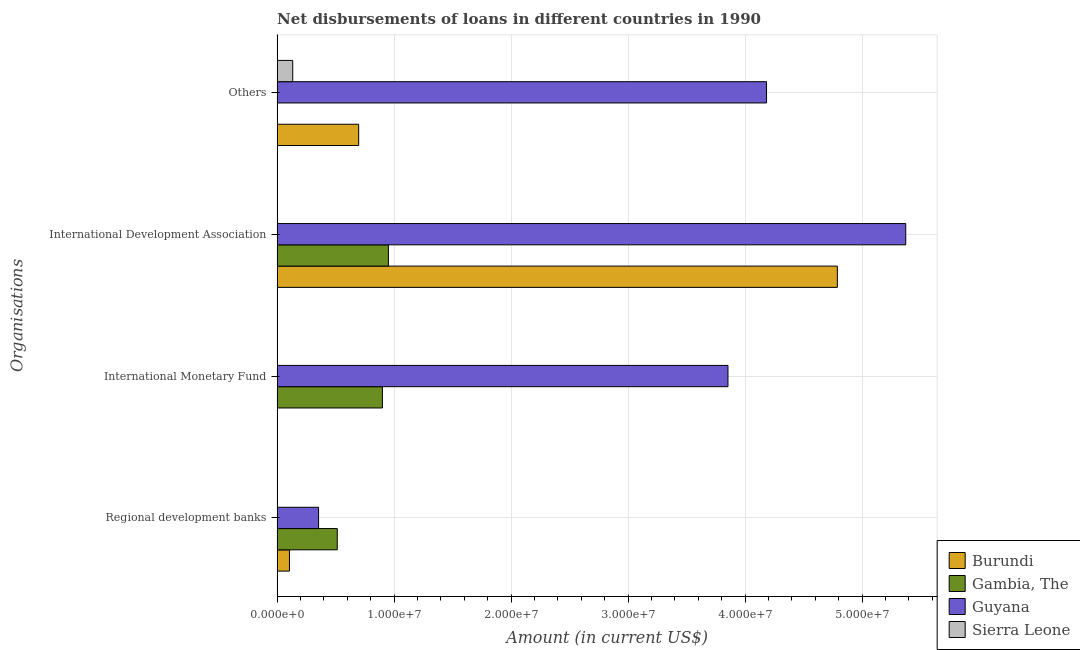How many different coloured bars are there?
Your response must be concise. 4. How many groups of bars are there?
Provide a succinct answer. 4. Are the number of bars per tick equal to the number of legend labels?
Provide a succinct answer. No. How many bars are there on the 4th tick from the bottom?
Your response must be concise. 3. What is the label of the 3rd group of bars from the top?
Provide a succinct answer. International Monetary Fund. What is the amount of loan disimbursed by international development association in Guyana?
Keep it short and to the point. 5.37e+07. Across all countries, what is the maximum amount of loan disimbursed by international monetary fund?
Ensure brevity in your answer.  3.85e+07. Across all countries, what is the minimum amount of loan disimbursed by regional development banks?
Keep it short and to the point. 0. In which country was the amount of loan disimbursed by international monetary fund maximum?
Your answer should be compact. Guyana. What is the total amount of loan disimbursed by other organisations in the graph?
Your answer should be compact. 5.01e+07. What is the difference between the amount of loan disimbursed by international development association in Gambia, The and that in Burundi?
Your response must be concise. -3.84e+07. What is the difference between the amount of loan disimbursed by regional development banks in Guyana and the amount of loan disimbursed by international development association in Burundi?
Your answer should be compact. -4.43e+07. What is the average amount of loan disimbursed by other organisations per country?
Keep it short and to the point. 1.25e+07. What is the difference between the amount of loan disimbursed by other organisations and amount of loan disimbursed by international development association in Burundi?
Make the answer very short. -4.09e+07. In how many countries, is the amount of loan disimbursed by international development association greater than 22000000 US$?
Ensure brevity in your answer.  2. What is the ratio of the amount of loan disimbursed by regional development banks in Gambia, The to that in Guyana?
Ensure brevity in your answer.  1.45. Is the amount of loan disimbursed by other organisations in Burundi less than that in Guyana?
Offer a very short reply. Yes. Is the difference between the amount of loan disimbursed by international development association in Sierra Leone and Guyana greater than the difference between the amount of loan disimbursed by other organisations in Sierra Leone and Guyana?
Provide a succinct answer. No. What is the difference between the highest and the second highest amount of loan disimbursed by regional development banks?
Offer a very short reply. 1.60e+06. What is the difference between the highest and the lowest amount of loan disimbursed by international development association?
Provide a succinct answer. 5.37e+07. Is it the case that in every country, the sum of the amount of loan disimbursed by regional development banks and amount of loan disimbursed by international monetary fund is greater than the amount of loan disimbursed by international development association?
Offer a very short reply. No. How many bars are there?
Keep it short and to the point. 12. Are all the bars in the graph horizontal?
Ensure brevity in your answer.  Yes. What is the difference between two consecutive major ticks on the X-axis?
Provide a succinct answer. 1.00e+07. Are the values on the major ticks of X-axis written in scientific E-notation?
Provide a short and direct response. Yes. Where does the legend appear in the graph?
Give a very brief answer. Bottom right. How are the legend labels stacked?
Make the answer very short. Vertical. What is the title of the graph?
Provide a short and direct response. Net disbursements of loans in different countries in 1990. Does "Small states" appear as one of the legend labels in the graph?
Give a very brief answer. No. What is the label or title of the Y-axis?
Provide a short and direct response. Organisations. What is the Amount (in current US$) in Burundi in Regional development banks?
Make the answer very short. 1.05e+06. What is the Amount (in current US$) in Gambia, The in Regional development banks?
Your answer should be compact. 5.14e+06. What is the Amount (in current US$) of Guyana in Regional development banks?
Keep it short and to the point. 3.54e+06. What is the Amount (in current US$) of Sierra Leone in Regional development banks?
Offer a terse response. 0. What is the Amount (in current US$) in Burundi in International Monetary Fund?
Your answer should be compact. 0. What is the Amount (in current US$) in Gambia, The in International Monetary Fund?
Provide a short and direct response. 9.00e+06. What is the Amount (in current US$) in Guyana in International Monetary Fund?
Offer a terse response. 3.85e+07. What is the Amount (in current US$) in Sierra Leone in International Monetary Fund?
Your response must be concise. 0. What is the Amount (in current US$) of Burundi in International Development Association?
Your answer should be compact. 4.79e+07. What is the Amount (in current US$) in Gambia, The in International Development Association?
Keep it short and to the point. 9.51e+06. What is the Amount (in current US$) in Guyana in International Development Association?
Make the answer very short. 5.37e+07. What is the Amount (in current US$) of Sierra Leone in International Development Association?
Your answer should be compact. 1.20e+04. What is the Amount (in current US$) in Burundi in Others?
Provide a succinct answer. 6.97e+06. What is the Amount (in current US$) of Guyana in Others?
Give a very brief answer. 4.18e+07. What is the Amount (in current US$) of Sierra Leone in Others?
Your answer should be compact. 1.33e+06. Across all Organisations, what is the maximum Amount (in current US$) in Burundi?
Provide a succinct answer. 4.79e+07. Across all Organisations, what is the maximum Amount (in current US$) in Gambia, The?
Offer a very short reply. 9.51e+06. Across all Organisations, what is the maximum Amount (in current US$) in Guyana?
Provide a short and direct response. 5.37e+07. Across all Organisations, what is the maximum Amount (in current US$) in Sierra Leone?
Provide a short and direct response. 1.33e+06. Across all Organisations, what is the minimum Amount (in current US$) in Burundi?
Provide a short and direct response. 0. Across all Organisations, what is the minimum Amount (in current US$) of Guyana?
Make the answer very short. 3.54e+06. What is the total Amount (in current US$) in Burundi in the graph?
Keep it short and to the point. 5.59e+07. What is the total Amount (in current US$) of Gambia, The in the graph?
Give a very brief answer. 2.36e+07. What is the total Amount (in current US$) in Guyana in the graph?
Provide a succinct answer. 1.38e+08. What is the total Amount (in current US$) in Sierra Leone in the graph?
Provide a short and direct response. 1.35e+06. What is the difference between the Amount (in current US$) in Gambia, The in Regional development banks and that in International Monetary Fund?
Offer a terse response. -3.86e+06. What is the difference between the Amount (in current US$) in Guyana in Regional development banks and that in International Monetary Fund?
Make the answer very short. -3.50e+07. What is the difference between the Amount (in current US$) of Burundi in Regional development banks and that in International Development Association?
Keep it short and to the point. -4.68e+07. What is the difference between the Amount (in current US$) in Gambia, The in Regional development banks and that in International Development Association?
Keep it short and to the point. -4.37e+06. What is the difference between the Amount (in current US$) of Guyana in Regional development banks and that in International Development Association?
Your answer should be compact. -5.02e+07. What is the difference between the Amount (in current US$) of Burundi in Regional development banks and that in Others?
Keep it short and to the point. -5.92e+06. What is the difference between the Amount (in current US$) in Guyana in Regional development banks and that in Others?
Provide a short and direct response. -3.83e+07. What is the difference between the Amount (in current US$) in Gambia, The in International Monetary Fund and that in International Development Association?
Give a very brief answer. -5.13e+05. What is the difference between the Amount (in current US$) of Guyana in International Monetary Fund and that in International Development Association?
Keep it short and to the point. -1.52e+07. What is the difference between the Amount (in current US$) in Guyana in International Monetary Fund and that in Others?
Your answer should be very brief. -3.30e+06. What is the difference between the Amount (in current US$) in Burundi in International Development Association and that in Others?
Your answer should be very brief. 4.09e+07. What is the difference between the Amount (in current US$) of Guyana in International Development Association and that in Others?
Your answer should be very brief. 1.19e+07. What is the difference between the Amount (in current US$) of Sierra Leone in International Development Association and that in Others?
Keep it short and to the point. -1.32e+06. What is the difference between the Amount (in current US$) in Burundi in Regional development banks and the Amount (in current US$) in Gambia, The in International Monetary Fund?
Provide a succinct answer. -7.94e+06. What is the difference between the Amount (in current US$) of Burundi in Regional development banks and the Amount (in current US$) of Guyana in International Monetary Fund?
Your answer should be compact. -3.75e+07. What is the difference between the Amount (in current US$) in Gambia, The in Regional development banks and the Amount (in current US$) in Guyana in International Monetary Fund?
Ensure brevity in your answer.  -3.34e+07. What is the difference between the Amount (in current US$) of Burundi in Regional development banks and the Amount (in current US$) of Gambia, The in International Development Association?
Provide a short and direct response. -8.46e+06. What is the difference between the Amount (in current US$) of Burundi in Regional development banks and the Amount (in current US$) of Guyana in International Development Association?
Give a very brief answer. -5.27e+07. What is the difference between the Amount (in current US$) of Burundi in Regional development banks and the Amount (in current US$) of Sierra Leone in International Development Association?
Make the answer very short. 1.04e+06. What is the difference between the Amount (in current US$) of Gambia, The in Regional development banks and the Amount (in current US$) of Guyana in International Development Association?
Your response must be concise. -4.86e+07. What is the difference between the Amount (in current US$) in Gambia, The in Regional development banks and the Amount (in current US$) in Sierra Leone in International Development Association?
Offer a terse response. 5.13e+06. What is the difference between the Amount (in current US$) of Guyana in Regional development banks and the Amount (in current US$) of Sierra Leone in International Development Association?
Offer a very short reply. 3.53e+06. What is the difference between the Amount (in current US$) of Burundi in Regional development banks and the Amount (in current US$) of Guyana in Others?
Keep it short and to the point. -4.08e+07. What is the difference between the Amount (in current US$) in Burundi in Regional development banks and the Amount (in current US$) in Sierra Leone in Others?
Offer a terse response. -2.82e+05. What is the difference between the Amount (in current US$) of Gambia, The in Regional development banks and the Amount (in current US$) of Guyana in Others?
Keep it short and to the point. -3.67e+07. What is the difference between the Amount (in current US$) of Gambia, The in Regional development banks and the Amount (in current US$) of Sierra Leone in Others?
Provide a succinct answer. 3.81e+06. What is the difference between the Amount (in current US$) in Guyana in Regional development banks and the Amount (in current US$) in Sierra Leone in Others?
Keep it short and to the point. 2.21e+06. What is the difference between the Amount (in current US$) in Gambia, The in International Monetary Fund and the Amount (in current US$) in Guyana in International Development Association?
Your answer should be compact. -4.47e+07. What is the difference between the Amount (in current US$) in Gambia, The in International Monetary Fund and the Amount (in current US$) in Sierra Leone in International Development Association?
Your answer should be very brief. 8.98e+06. What is the difference between the Amount (in current US$) in Guyana in International Monetary Fund and the Amount (in current US$) in Sierra Leone in International Development Association?
Keep it short and to the point. 3.85e+07. What is the difference between the Amount (in current US$) of Gambia, The in International Monetary Fund and the Amount (in current US$) of Guyana in Others?
Keep it short and to the point. -3.28e+07. What is the difference between the Amount (in current US$) of Gambia, The in International Monetary Fund and the Amount (in current US$) of Sierra Leone in Others?
Ensure brevity in your answer.  7.66e+06. What is the difference between the Amount (in current US$) in Guyana in International Monetary Fund and the Amount (in current US$) in Sierra Leone in Others?
Make the answer very short. 3.72e+07. What is the difference between the Amount (in current US$) in Burundi in International Development Association and the Amount (in current US$) in Guyana in Others?
Your answer should be very brief. 6.05e+06. What is the difference between the Amount (in current US$) in Burundi in International Development Association and the Amount (in current US$) in Sierra Leone in Others?
Offer a terse response. 4.65e+07. What is the difference between the Amount (in current US$) of Gambia, The in International Development Association and the Amount (in current US$) of Guyana in Others?
Make the answer very short. -3.23e+07. What is the difference between the Amount (in current US$) in Gambia, The in International Development Association and the Amount (in current US$) in Sierra Leone in Others?
Your response must be concise. 8.18e+06. What is the difference between the Amount (in current US$) in Guyana in International Development Association and the Amount (in current US$) in Sierra Leone in Others?
Your response must be concise. 5.24e+07. What is the average Amount (in current US$) in Burundi per Organisations?
Ensure brevity in your answer.  1.40e+07. What is the average Amount (in current US$) in Gambia, The per Organisations?
Give a very brief answer. 5.91e+06. What is the average Amount (in current US$) in Guyana per Organisations?
Ensure brevity in your answer.  3.44e+07. What is the average Amount (in current US$) in Sierra Leone per Organisations?
Provide a short and direct response. 3.36e+05. What is the difference between the Amount (in current US$) of Burundi and Amount (in current US$) of Gambia, The in Regional development banks?
Offer a very short reply. -4.09e+06. What is the difference between the Amount (in current US$) in Burundi and Amount (in current US$) in Guyana in Regional development banks?
Provide a succinct answer. -2.49e+06. What is the difference between the Amount (in current US$) in Gambia, The and Amount (in current US$) in Guyana in Regional development banks?
Offer a very short reply. 1.60e+06. What is the difference between the Amount (in current US$) of Gambia, The and Amount (in current US$) of Guyana in International Monetary Fund?
Offer a very short reply. -2.95e+07. What is the difference between the Amount (in current US$) in Burundi and Amount (in current US$) in Gambia, The in International Development Association?
Your answer should be compact. 3.84e+07. What is the difference between the Amount (in current US$) in Burundi and Amount (in current US$) in Guyana in International Development Association?
Your response must be concise. -5.84e+06. What is the difference between the Amount (in current US$) of Burundi and Amount (in current US$) of Sierra Leone in International Development Association?
Provide a short and direct response. 4.79e+07. What is the difference between the Amount (in current US$) of Gambia, The and Amount (in current US$) of Guyana in International Development Association?
Your answer should be compact. -4.42e+07. What is the difference between the Amount (in current US$) of Gambia, The and Amount (in current US$) of Sierra Leone in International Development Association?
Provide a short and direct response. 9.50e+06. What is the difference between the Amount (in current US$) in Guyana and Amount (in current US$) in Sierra Leone in International Development Association?
Offer a very short reply. 5.37e+07. What is the difference between the Amount (in current US$) of Burundi and Amount (in current US$) of Guyana in Others?
Ensure brevity in your answer.  -3.49e+07. What is the difference between the Amount (in current US$) of Burundi and Amount (in current US$) of Sierra Leone in Others?
Give a very brief answer. 5.64e+06. What is the difference between the Amount (in current US$) of Guyana and Amount (in current US$) of Sierra Leone in Others?
Your response must be concise. 4.05e+07. What is the ratio of the Amount (in current US$) in Gambia, The in Regional development banks to that in International Monetary Fund?
Keep it short and to the point. 0.57. What is the ratio of the Amount (in current US$) of Guyana in Regional development banks to that in International Monetary Fund?
Offer a very short reply. 0.09. What is the ratio of the Amount (in current US$) in Burundi in Regional development banks to that in International Development Association?
Give a very brief answer. 0.02. What is the ratio of the Amount (in current US$) in Gambia, The in Regional development banks to that in International Development Association?
Give a very brief answer. 0.54. What is the ratio of the Amount (in current US$) in Guyana in Regional development banks to that in International Development Association?
Keep it short and to the point. 0.07. What is the ratio of the Amount (in current US$) of Burundi in Regional development banks to that in Others?
Your answer should be compact. 0.15. What is the ratio of the Amount (in current US$) in Guyana in Regional development banks to that in Others?
Your response must be concise. 0.08. What is the ratio of the Amount (in current US$) of Gambia, The in International Monetary Fund to that in International Development Association?
Provide a short and direct response. 0.95. What is the ratio of the Amount (in current US$) in Guyana in International Monetary Fund to that in International Development Association?
Offer a very short reply. 0.72. What is the ratio of the Amount (in current US$) in Guyana in International Monetary Fund to that in Others?
Offer a terse response. 0.92. What is the ratio of the Amount (in current US$) in Burundi in International Development Association to that in Others?
Give a very brief answer. 6.87. What is the ratio of the Amount (in current US$) of Guyana in International Development Association to that in Others?
Your response must be concise. 1.28. What is the ratio of the Amount (in current US$) in Sierra Leone in International Development Association to that in Others?
Offer a terse response. 0.01. What is the difference between the highest and the second highest Amount (in current US$) in Burundi?
Offer a terse response. 4.09e+07. What is the difference between the highest and the second highest Amount (in current US$) of Gambia, The?
Ensure brevity in your answer.  5.13e+05. What is the difference between the highest and the second highest Amount (in current US$) of Guyana?
Offer a terse response. 1.19e+07. What is the difference between the highest and the lowest Amount (in current US$) of Burundi?
Ensure brevity in your answer.  4.79e+07. What is the difference between the highest and the lowest Amount (in current US$) in Gambia, The?
Give a very brief answer. 9.51e+06. What is the difference between the highest and the lowest Amount (in current US$) in Guyana?
Give a very brief answer. 5.02e+07. What is the difference between the highest and the lowest Amount (in current US$) of Sierra Leone?
Provide a short and direct response. 1.33e+06. 